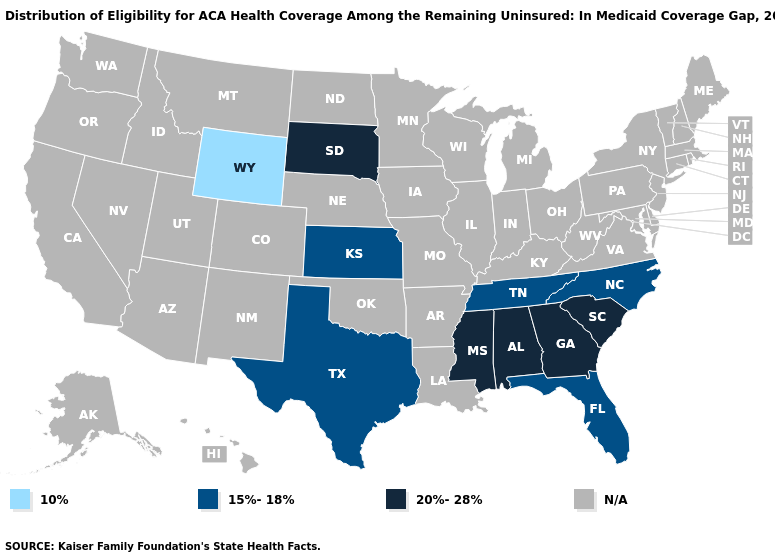What is the lowest value in the West?
Give a very brief answer. 10%. What is the value of Tennessee?
Answer briefly. 15%-18%. Does the first symbol in the legend represent the smallest category?
Give a very brief answer. Yes. What is the lowest value in the West?
Concise answer only. 10%. Does the first symbol in the legend represent the smallest category?
Be succinct. Yes. What is the value of Georgia?
Answer briefly. 20%-28%. 